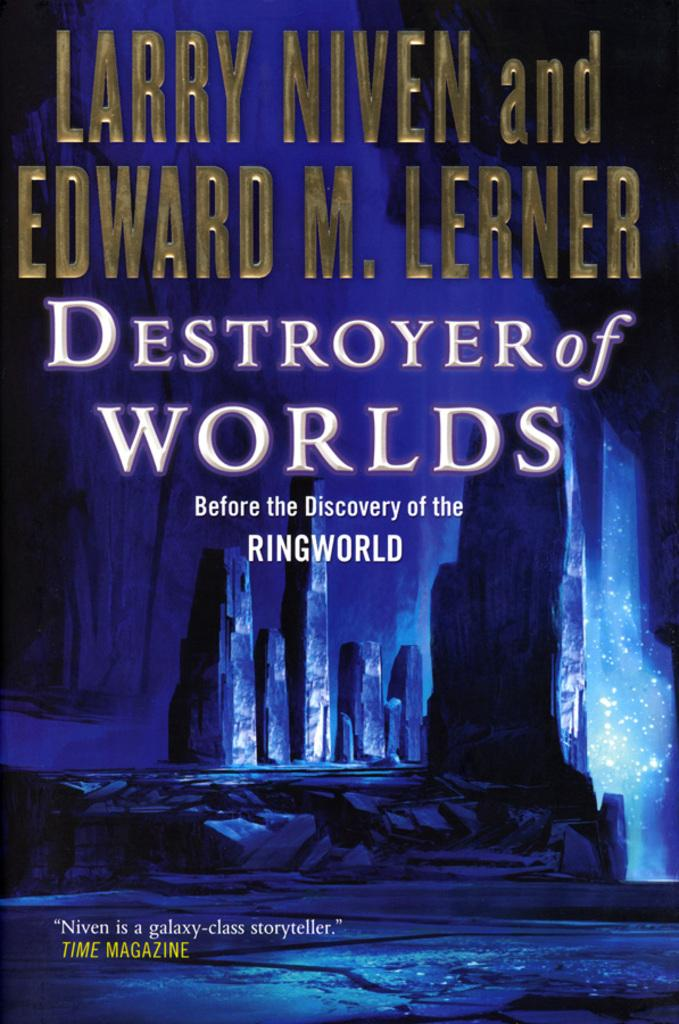<image>
Write a terse but informative summary of the picture. larry niven and edward m lerner's book destroyer of worlds 